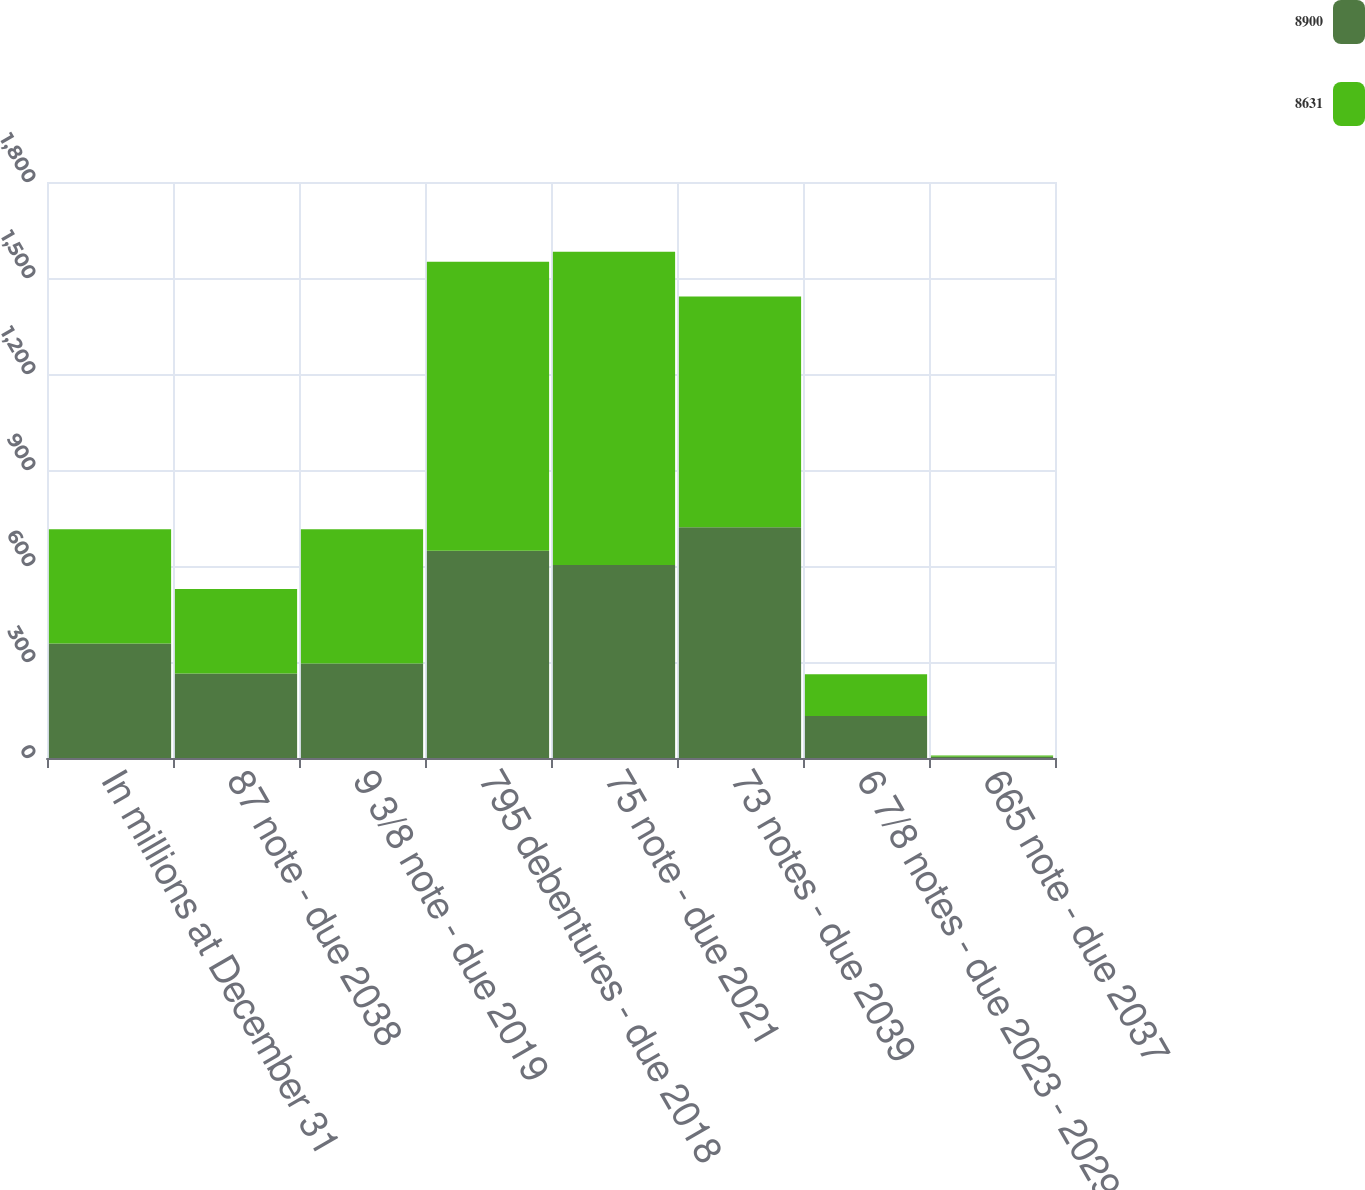Convert chart. <chart><loc_0><loc_0><loc_500><loc_500><stacked_bar_chart><ecel><fcel>In millions at December 31<fcel>87 note - due 2038<fcel>9 3/8 note - due 2019<fcel>795 debentures - due 2018<fcel>75 note - due 2021<fcel>73 notes - due 2039<fcel>6 7/8 notes - due 2023 - 2029<fcel>665 note - due 2037<nl><fcel>8900<fcel>357.5<fcel>264<fcel>295<fcel>648<fcel>603<fcel>721<fcel>131<fcel>4<nl><fcel>8631<fcel>357.5<fcel>264<fcel>420<fcel>903<fcel>979<fcel>721<fcel>131<fcel>4<nl></chart> 